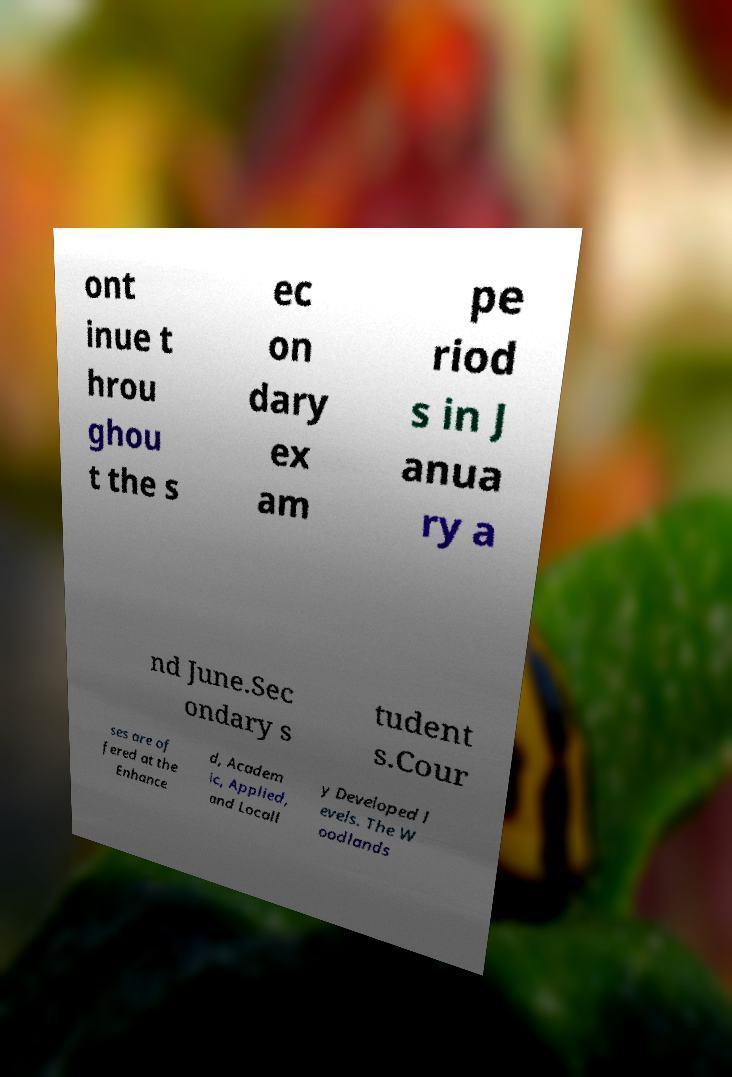Please identify and transcribe the text found in this image. ont inue t hrou ghou t the s ec on dary ex am pe riod s in J anua ry a nd June.Sec ondary s tudent s.Cour ses are of fered at the Enhance d, Academ ic, Applied, and Locall y Developed l evels. The W oodlands 